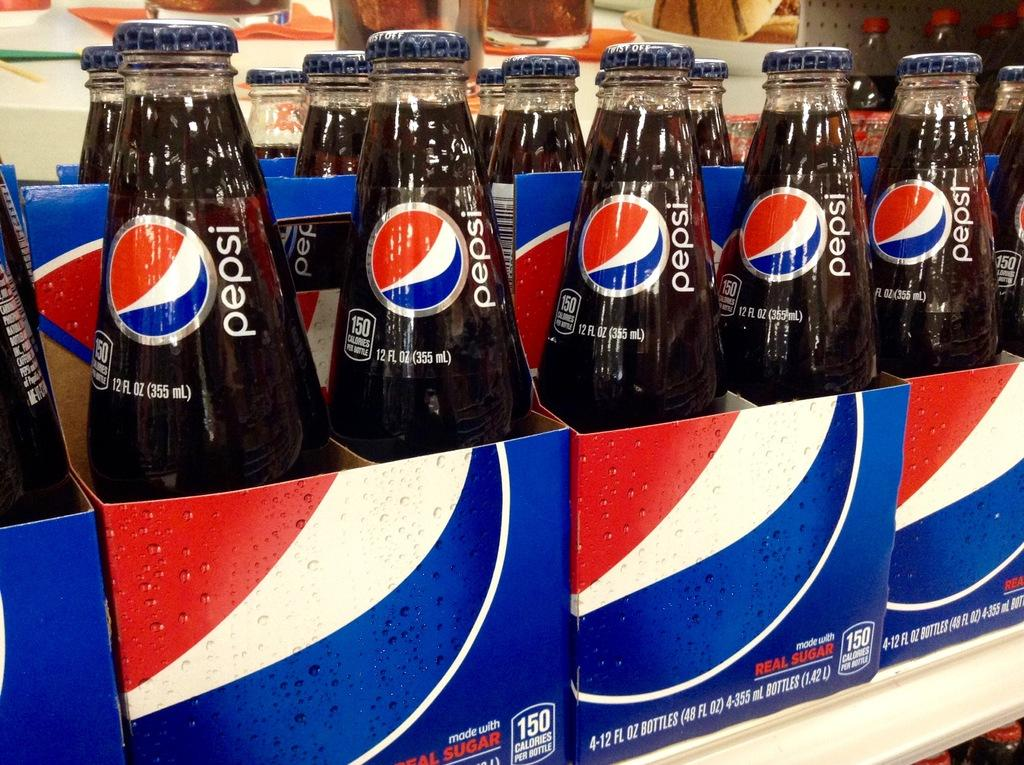Provide a one-sentence caption for the provided image. Glass bottles of Pepsi in a building being sold. 